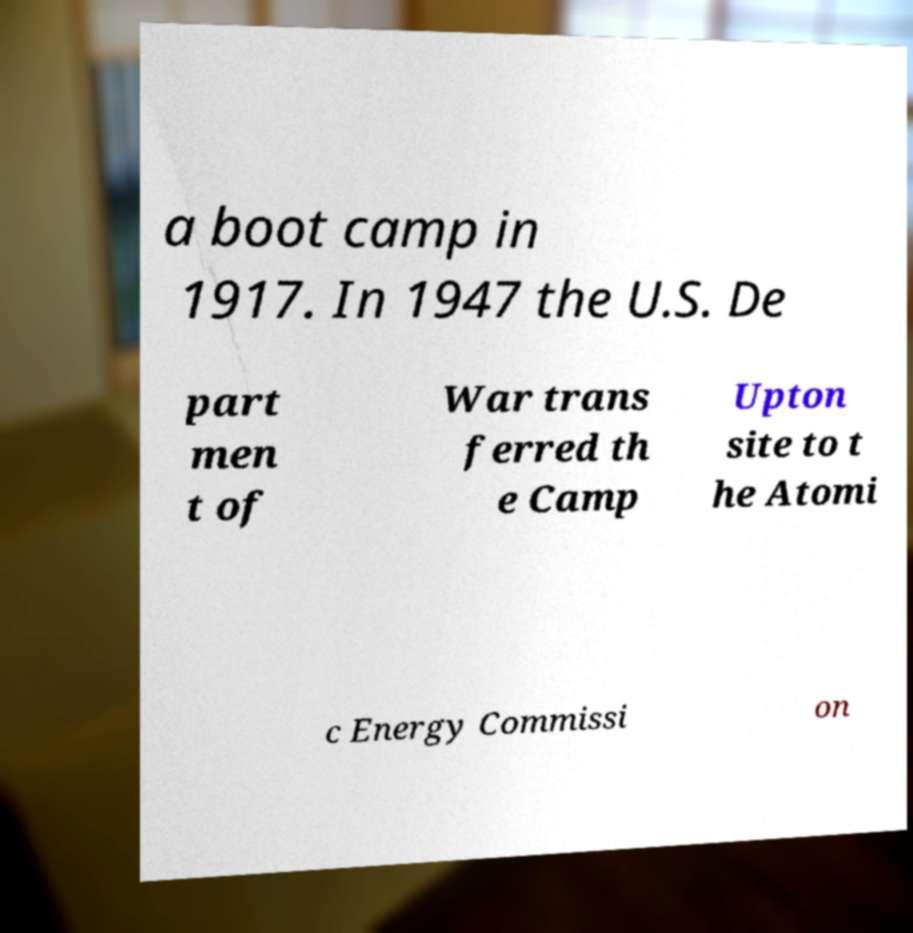Can you read and provide the text displayed in the image?This photo seems to have some interesting text. Can you extract and type it out for me? a boot camp in 1917. In 1947 the U.S. De part men t of War trans ferred th e Camp Upton site to t he Atomi c Energy Commissi on 